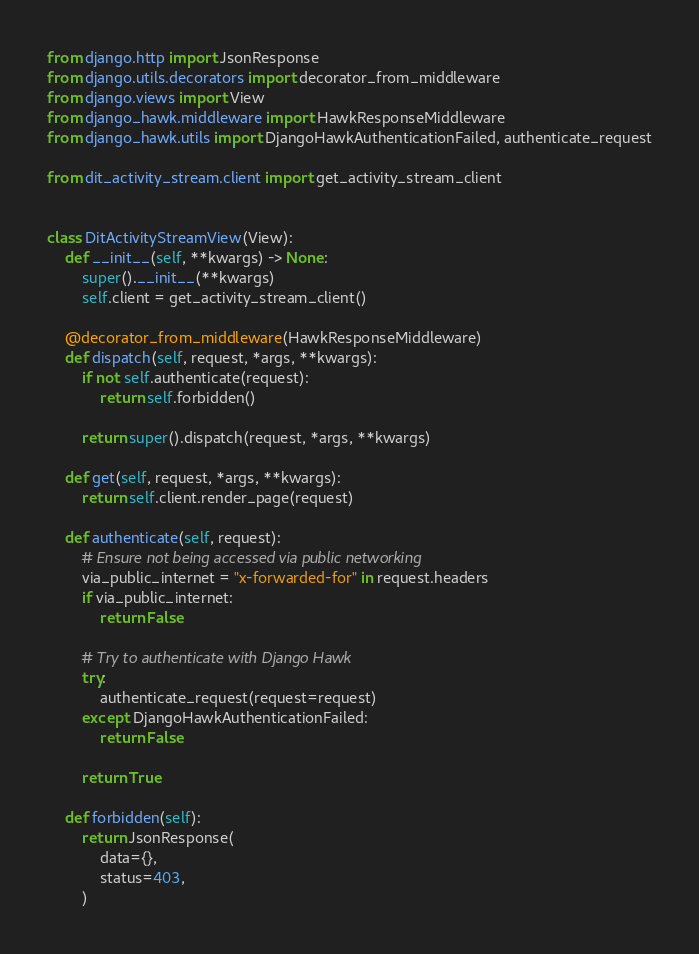<code> <loc_0><loc_0><loc_500><loc_500><_Python_>from django.http import JsonResponse
from django.utils.decorators import decorator_from_middleware
from django.views import View
from django_hawk.middleware import HawkResponseMiddleware
from django_hawk.utils import DjangoHawkAuthenticationFailed, authenticate_request

from dit_activity_stream.client import get_activity_stream_client


class DitActivityStreamView(View):
    def __init__(self, **kwargs) -> None:
        super().__init__(**kwargs)
        self.client = get_activity_stream_client()

    @decorator_from_middleware(HawkResponseMiddleware)
    def dispatch(self, request, *args, **kwargs):
        if not self.authenticate(request):
            return self.forbidden()

        return super().dispatch(request, *args, **kwargs)

    def get(self, request, *args, **kwargs):
        return self.client.render_page(request)

    def authenticate(self, request):
        # Ensure not being accessed via public networking
        via_public_internet = "x-forwarded-for" in request.headers
        if via_public_internet:
            return False

        # Try to authenticate with Django Hawk
        try:
            authenticate_request(request=request)
        except DjangoHawkAuthenticationFailed:
            return False

        return True

    def forbidden(self):
        return JsonResponse(
            data={},
            status=403,
        )
</code> 